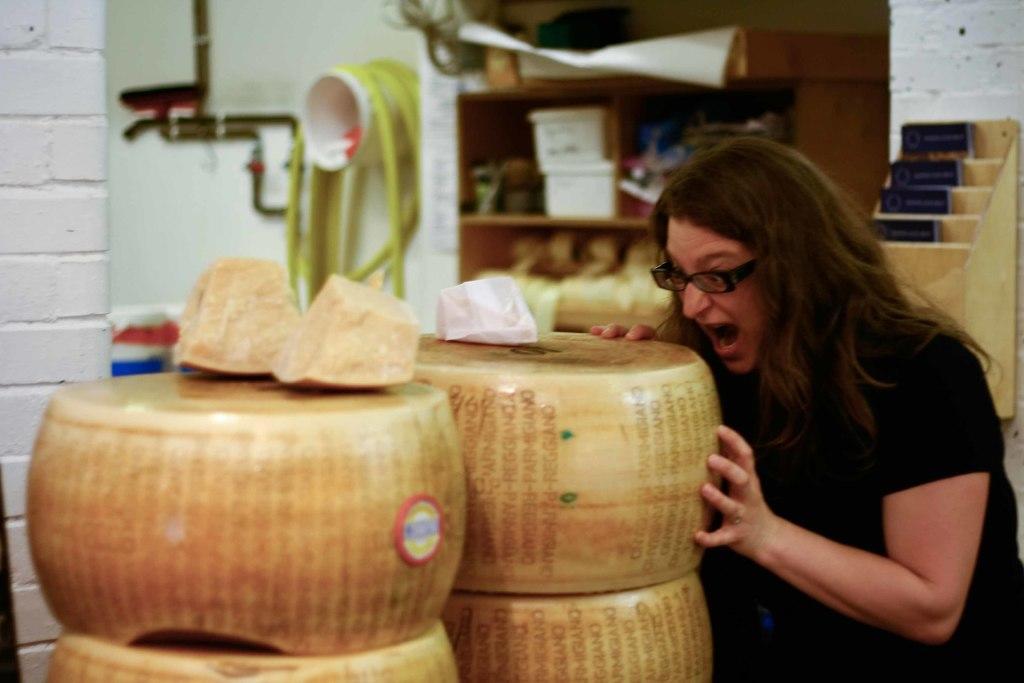In one or two sentences, can you explain what this image depicts? In this image we can see a woman wearing black dress and spectacles. Here we can see some objects. The background the images slightly blurred, where we can see the brick wall, pipes and wooden cupboards in which we can see some things are kept. 